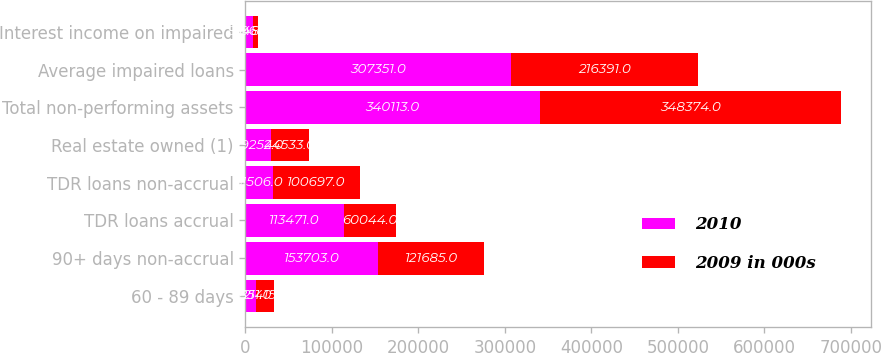Convert chart to OTSL. <chart><loc_0><loc_0><loc_500><loc_500><stacked_bar_chart><ecel><fcel>60 - 89 days<fcel>90+ days non-accrual<fcel>TDR loans accrual<fcel>TDR loans non-accrual<fcel>Real estate owned (1)<fcel>Total non-performing assets<fcel>Average impaired loans<fcel>Interest income on impaired<nl><fcel>2010<fcel>11851<fcel>153703<fcel>113471<fcel>31506<fcel>29252<fcel>340113<fcel>307351<fcel>8548<nl><fcel>2009 in 000s<fcel>21415<fcel>121685<fcel>60044<fcel>100697<fcel>44533<fcel>348374<fcel>216391<fcel>5964<nl></chart> 